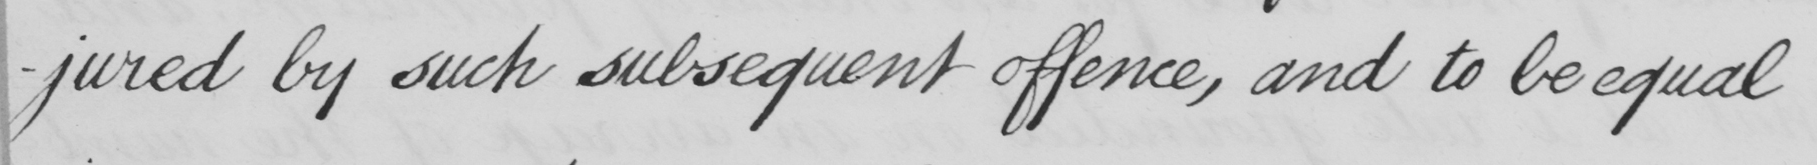What does this handwritten line say? -jured by such subsequent offence , and to be equal 